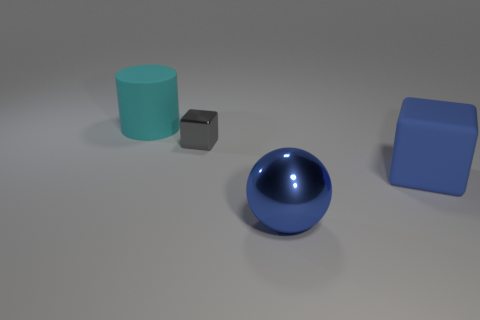Can you describe the different objects and their materials that are present in the image? Certainly! There are four objects in the image. On the left, there's a teal cylinder that looks like it's made of rubber due to its matte finish. Next to it, there's a small dark grey cube that also seems to be made of a matte material, possibly plastic. In the center, there's a shiny blue sphere that gives the impression of being metallic because of its reflective surface. And finally, on the right, we have a large blue block with a matte finish, potentially also rubber or a similar material. 